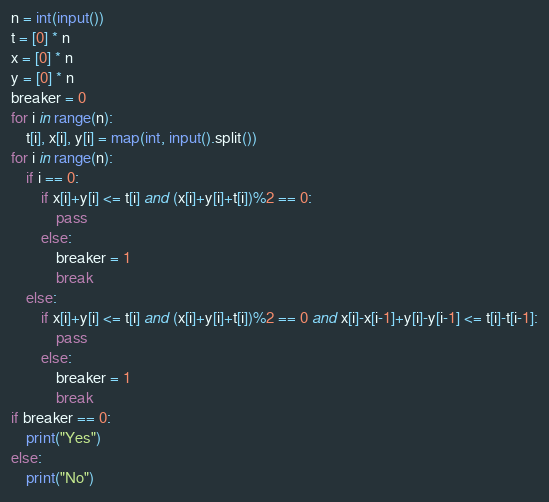<code> <loc_0><loc_0><loc_500><loc_500><_Python_>n = int(input())
t = [0] * n
x = [0] * n
y = [0] * n
breaker = 0
for i in range(n):
    t[i], x[i], y[i] = map(int, input().split())
for i in range(n):
    if i == 0:
        if x[i]+y[i] <= t[i] and (x[i]+y[i]+t[i])%2 == 0:
            pass
        else:
            breaker = 1
            break
    else:
        if x[i]+y[i] <= t[i] and (x[i]+y[i]+t[i])%2 == 0 and x[i]-x[i-1]+y[i]-y[i-1] <= t[i]-t[i-1]:
            pass
        else:
            breaker = 1
            break
if breaker == 0:
    print("Yes")
else:
    print("No")</code> 